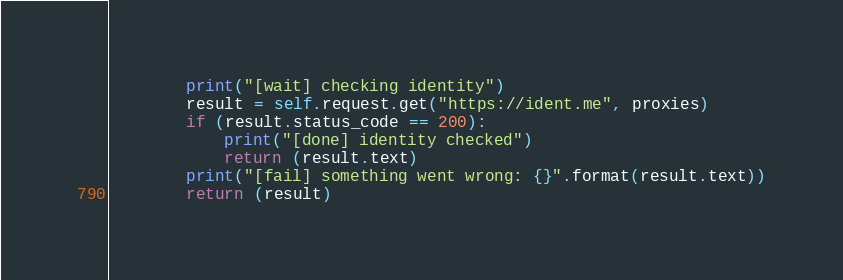Convert code to text. <code><loc_0><loc_0><loc_500><loc_500><_Python_>        print("[wait] checking identity")
        result = self.request.get("https://ident.me", proxies)
        if (result.status_code == 200):
            print("[done] identity checked")
            return (result.text)
        print("[fail] something went wrong: {}".format(result.text))
        return (result)
</code> 